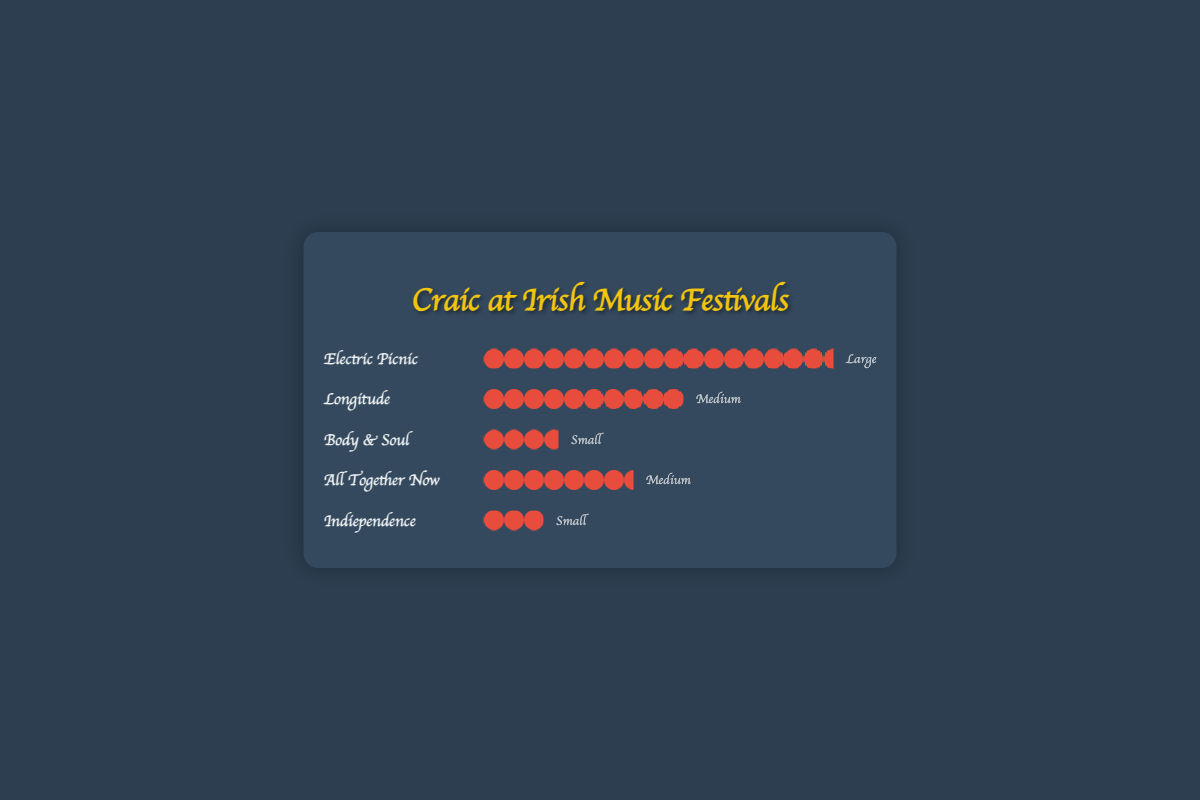What's the title of the figure? The title of the figure is displayed at the top and reads: "Craic at Irish Music Festivals."
Answer: Craic at Irish Music Festivals Which music festival has the highest attendance? The festival with the highest attendance has the most icons in the row representing it. "Electric Picnic" has the most icons.
Answer: Electric Picnic Which festivals are categorized as 'Medium' size? Festivals in the 'Medium' size category have the size label "Medium" next to their names. These festivals are "Longitude" and "All Together Now."
Answer: Longitude, All Together Now How many times greater is the attendance of Electric Picnic compared to Indiependence? To find how many times greater the attendance at Electric Picnic is compared to Indiependence, divide the attendance of Electric Picnic (70000) by that of Indiependence (12000). The result is approximately 5.83.
Answer: Approximately 5.83 What is the combined attendance of all the 'Small' sized festivals? The 'Small' sized festivals are "Body & Soul" and "Indiependence." Their attendances are 15000 and 12000, respectively. Adding these together gives 15000 + 12000 = 27000.
Answer: 27000 Which festival has the second highest attendance? The festival with the second highest attendance will have the second most icons. "Longitude" with an attendance of 40000, has the second most icons after Electric Picnic.
Answer: Longitude What is the average attendance of the 'Medium' sized festivals? The 'Medium' sized festivals are "Longitude" (40000) and "All Together Now" (30000). The average attendance is calculated by adding their attendances and dividing by 2. (40000 + 30000) / 2 = 35000.
Answer: 35000 Compare the attendance of Body & Soul and All Together Now. Which has higher attendance? By checking the icons, Body & Soul (15000) and All Together Now (30000), "All Together Now" has a higher attendance.
Answer: All Together Now 